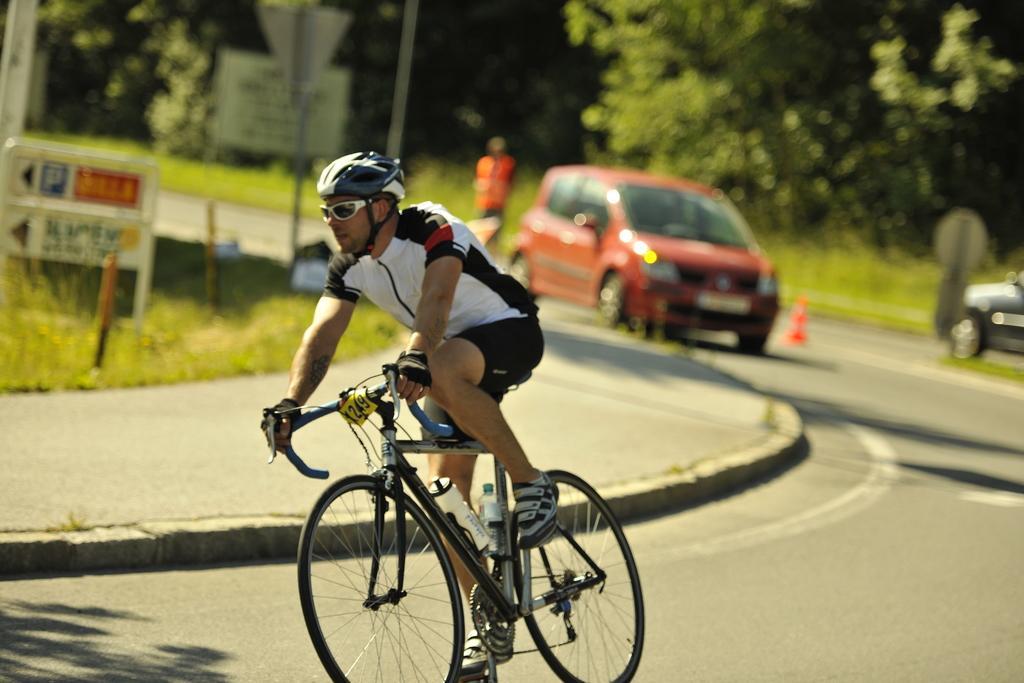How would you summarize this image in a sentence or two? This image contains a person riding a bi-cycle wearing shoes, helmet and goggles. Two bottles are attached to the bicycle. Right side there is a car. MIddle of image there is a car on the road. Left side there is a pavement beside there is a grass on which a sign board is there. At the background there are few trees and grass. A person is standing on the grass backside. 